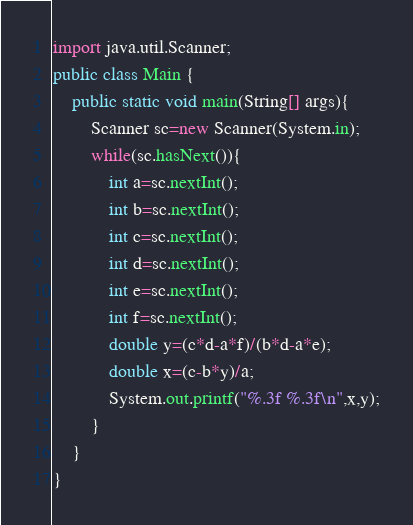<code> <loc_0><loc_0><loc_500><loc_500><_Java_>import java.util.Scanner;
public class Main {
	public static void main(String[] args){
		Scanner sc=new Scanner(System.in);
		while(sc.hasNext()){
			int a=sc.nextInt();
			int b=sc.nextInt();
			int c=sc.nextInt();
			int d=sc.nextInt();
			int e=sc.nextInt();
			int f=sc.nextInt();
			double y=(c*d-a*f)/(b*d-a*e);
			double x=(c-b*y)/a;
			System.out.printf("%.3f %.3f\n",x,y);
		}
	}
}</code> 